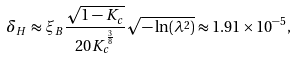Convert formula to latex. <formula><loc_0><loc_0><loc_500><loc_500>\delta _ { H } \approx \xi _ { B } \frac { \sqrt { 1 - K _ { c } } } { 2 0 K _ { c } ^ { \frac { 3 } { 8 } } } \sqrt { - \ln ( \lambda ^ { 2 } ) } \approx 1 . 9 1 \times 1 0 ^ { - 5 } ,</formula> 